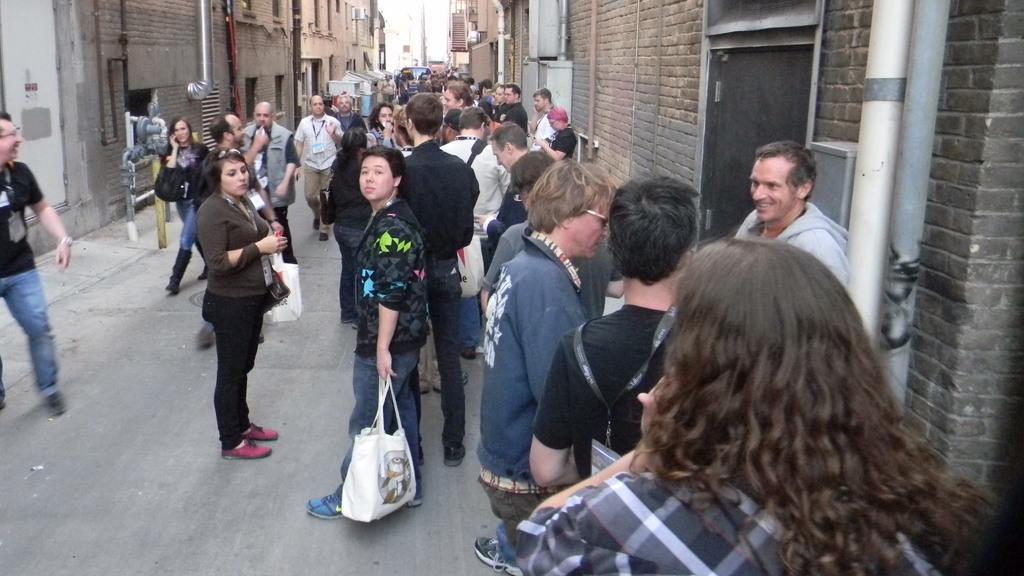Could you give a brief overview of what you see in this image? In this image there are few persons standing on the street lane. A person is carrying a bag. He is standing before a person wearing black shirt. There is a vehicle on the road. Few metal pipes are on the pavement. Background there are few buildings. 